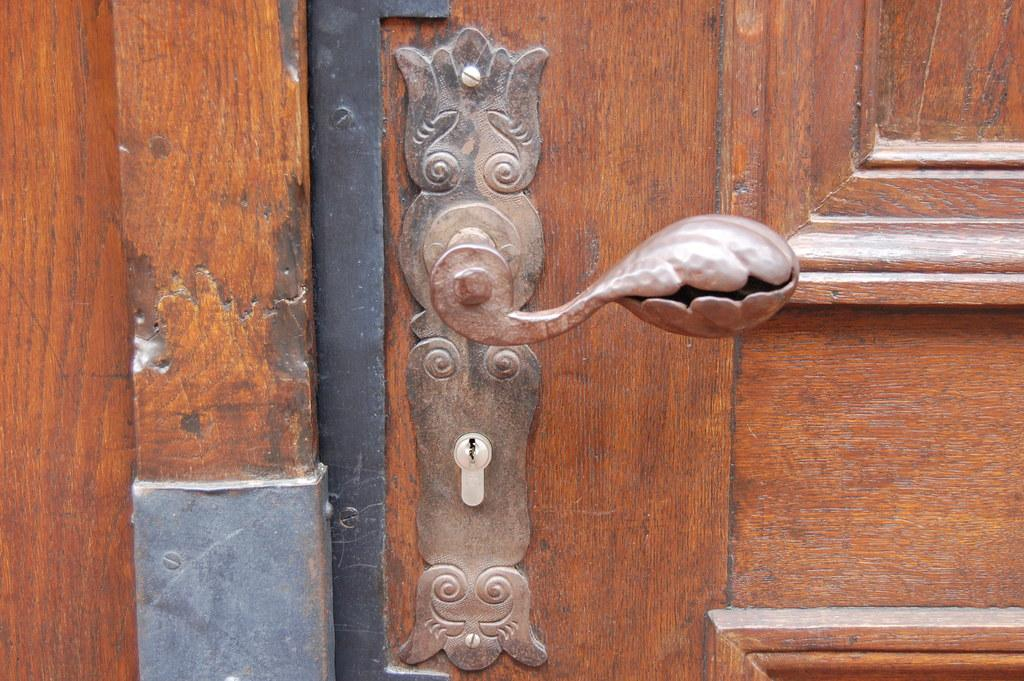What is the main object in the image? There is a door lock in the image. Can you describe the door that the lock is attached to? The door is brown in color. What type of music can be heard playing in the background of the image? There is no music present in the image; it only features a door lock and a brown door. 